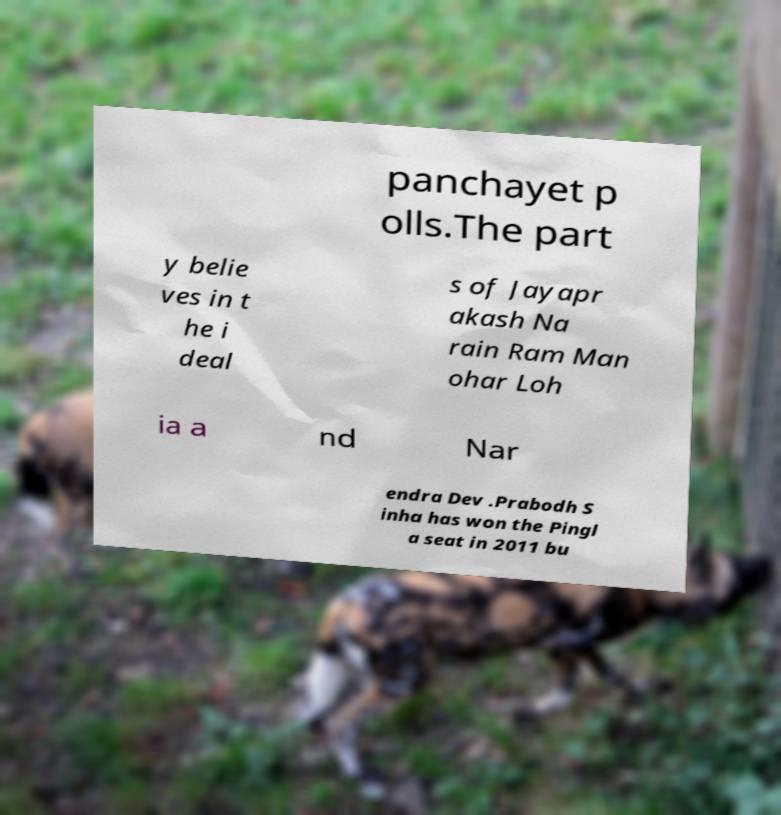Can you read and provide the text displayed in the image?This photo seems to have some interesting text. Can you extract and type it out for me? panchayet p olls.The part y belie ves in t he i deal s of Jayapr akash Na rain Ram Man ohar Loh ia a nd Nar endra Dev .Prabodh S inha has won the Pingl a seat in 2011 bu 